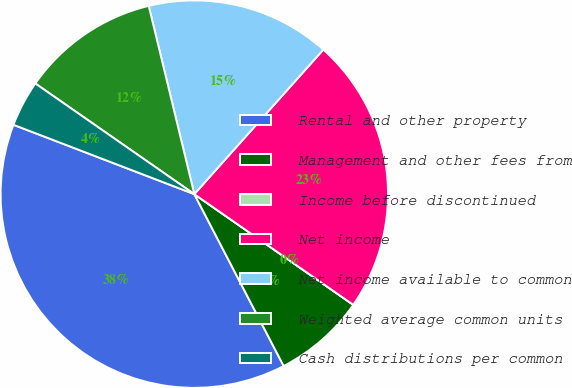<chart> <loc_0><loc_0><loc_500><loc_500><pie_chart><fcel>Rental and other property<fcel>Management and other fees from<fcel>Income before discontinued<fcel>Net income<fcel>Net income available to common<fcel>Weighted average common units<fcel>Cash distributions per common<nl><fcel>38.46%<fcel>7.69%<fcel>0.0%<fcel>23.08%<fcel>15.38%<fcel>11.54%<fcel>3.85%<nl></chart> 